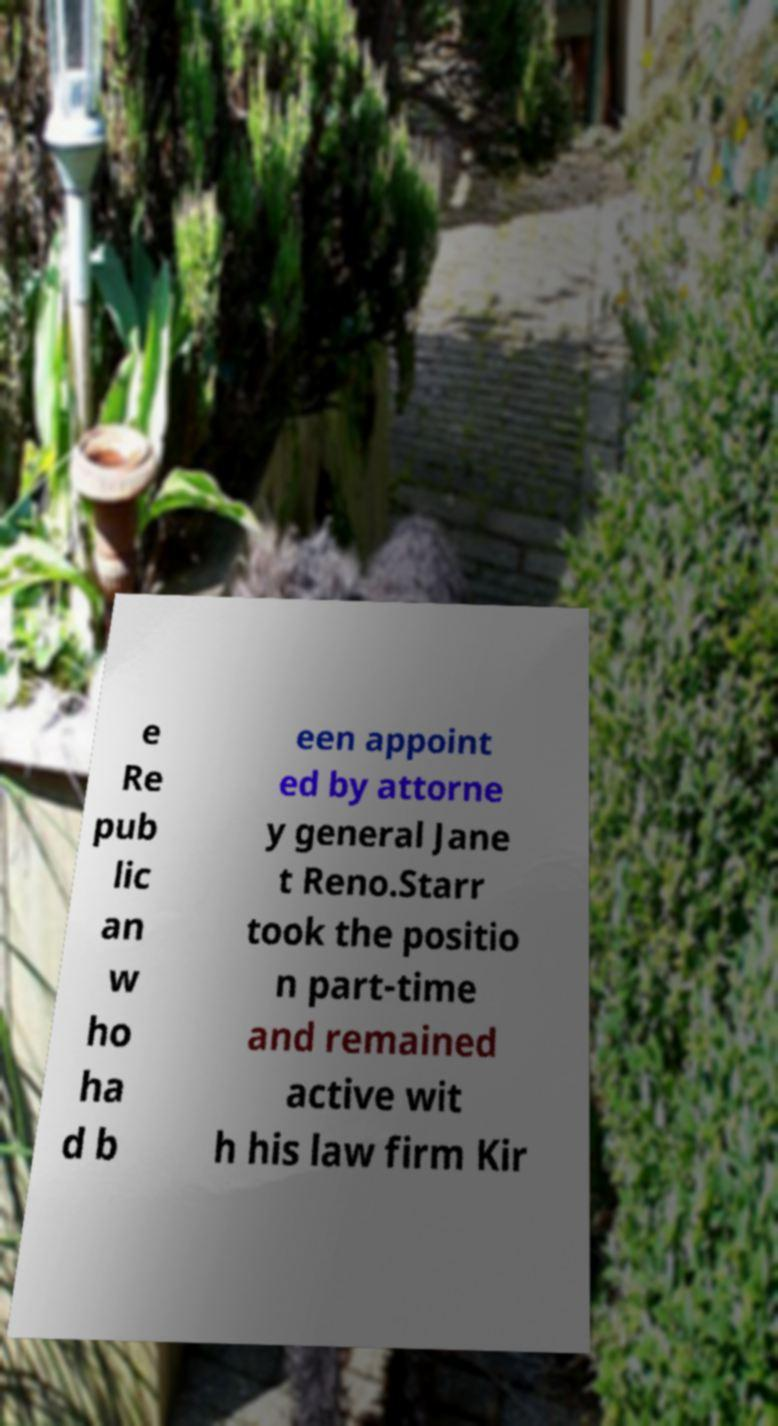Can you read and provide the text displayed in the image?This photo seems to have some interesting text. Can you extract and type it out for me? e Re pub lic an w ho ha d b een appoint ed by attorne y general Jane t Reno.Starr took the positio n part-time and remained active wit h his law firm Kir 